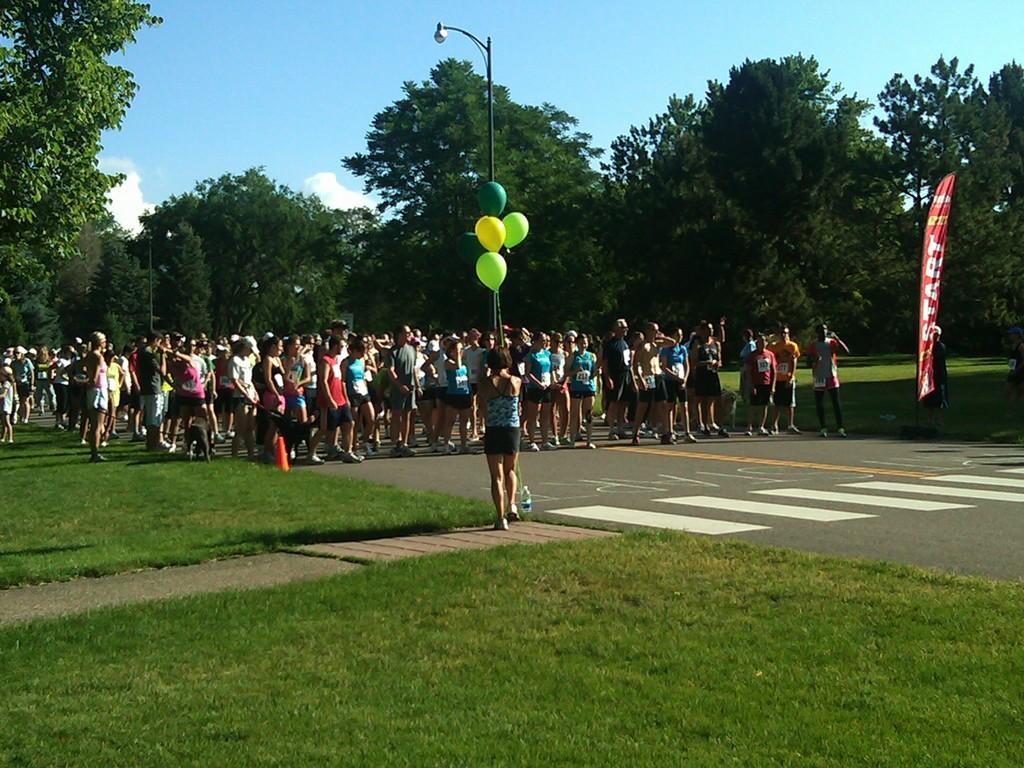Describe this image in one or two sentences. In this picture there is a woman standing and there is a pole,balloons and few persons standing in front of her and there are trees in the background and there is a red banner which has something written on it in the right corner. 